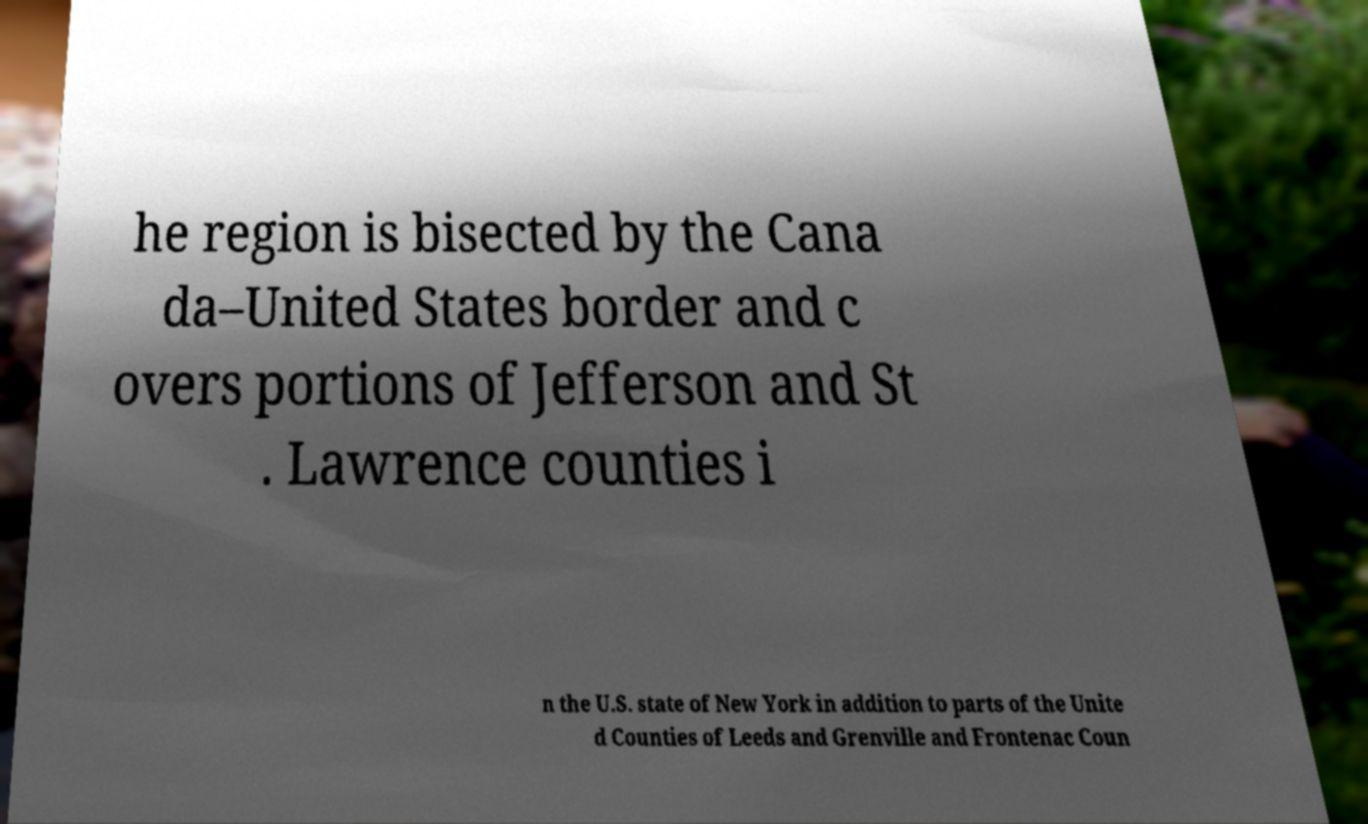What messages or text are displayed in this image? I need them in a readable, typed format. he region is bisected by the Cana da–United States border and c overs portions of Jefferson and St . Lawrence counties i n the U.S. state of New York in addition to parts of the Unite d Counties of Leeds and Grenville and Frontenac Coun 